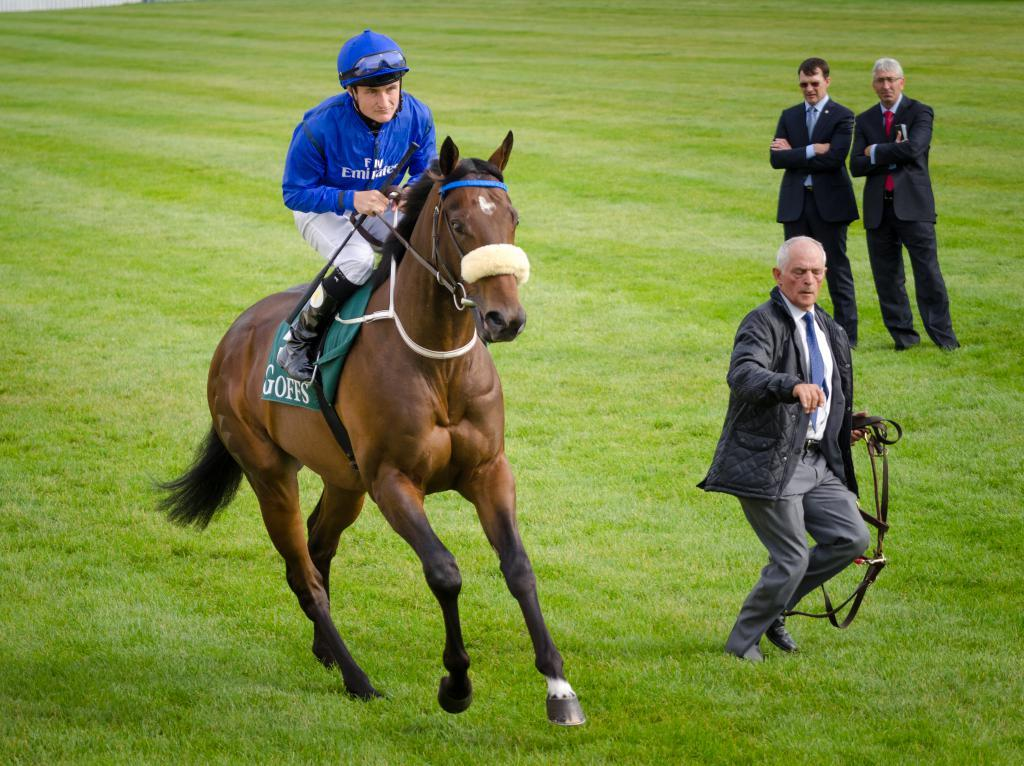How many people are in the image? There are four people in the image. Where are the people located in the image? The people are on the left side of the image. What is one of the people doing in the image? One man is riding a horse. What is the position of the horse in the image? The horse is on the ground. What type of copper object can be seen in the image? There is no copper object present in the image. What day of the week is depicted in the image? The image does not depict a specific day of the week. 